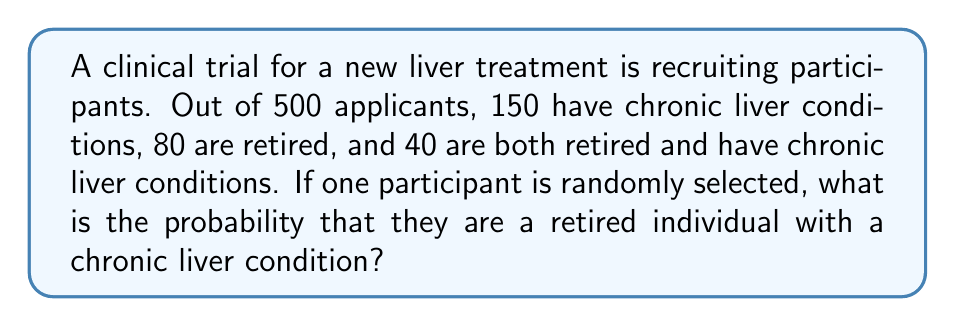Can you answer this question? Let's approach this step-by-step using the given information:

1. Total number of applicants: $n = 500$
2. Number of applicants with chronic liver conditions: $A = 150$
3. Number of retired applicants: $B = 80$
4. Number of applicants who are both retired and have chronic liver conditions: $A \cap B = 40$

We need to find $P(A \cap B)$, which is the probability of selecting a retired individual with a chronic liver condition.

The probability is calculated by dividing the number of favorable outcomes by the total number of possible outcomes:

$$P(A \cap B) = \frac{|A \cap B|}{n}$$

Where $|A \cap B|$ is the number of applicants who are both retired and have chronic liver conditions.

Substituting the values:

$$P(A \cap B) = \frac{40}{500} = \frac{2}{25} = 0.08$$

To express this as a percentage:

$$0.08 \times 100\% = 8\%$$
Answer: $8\%$ 